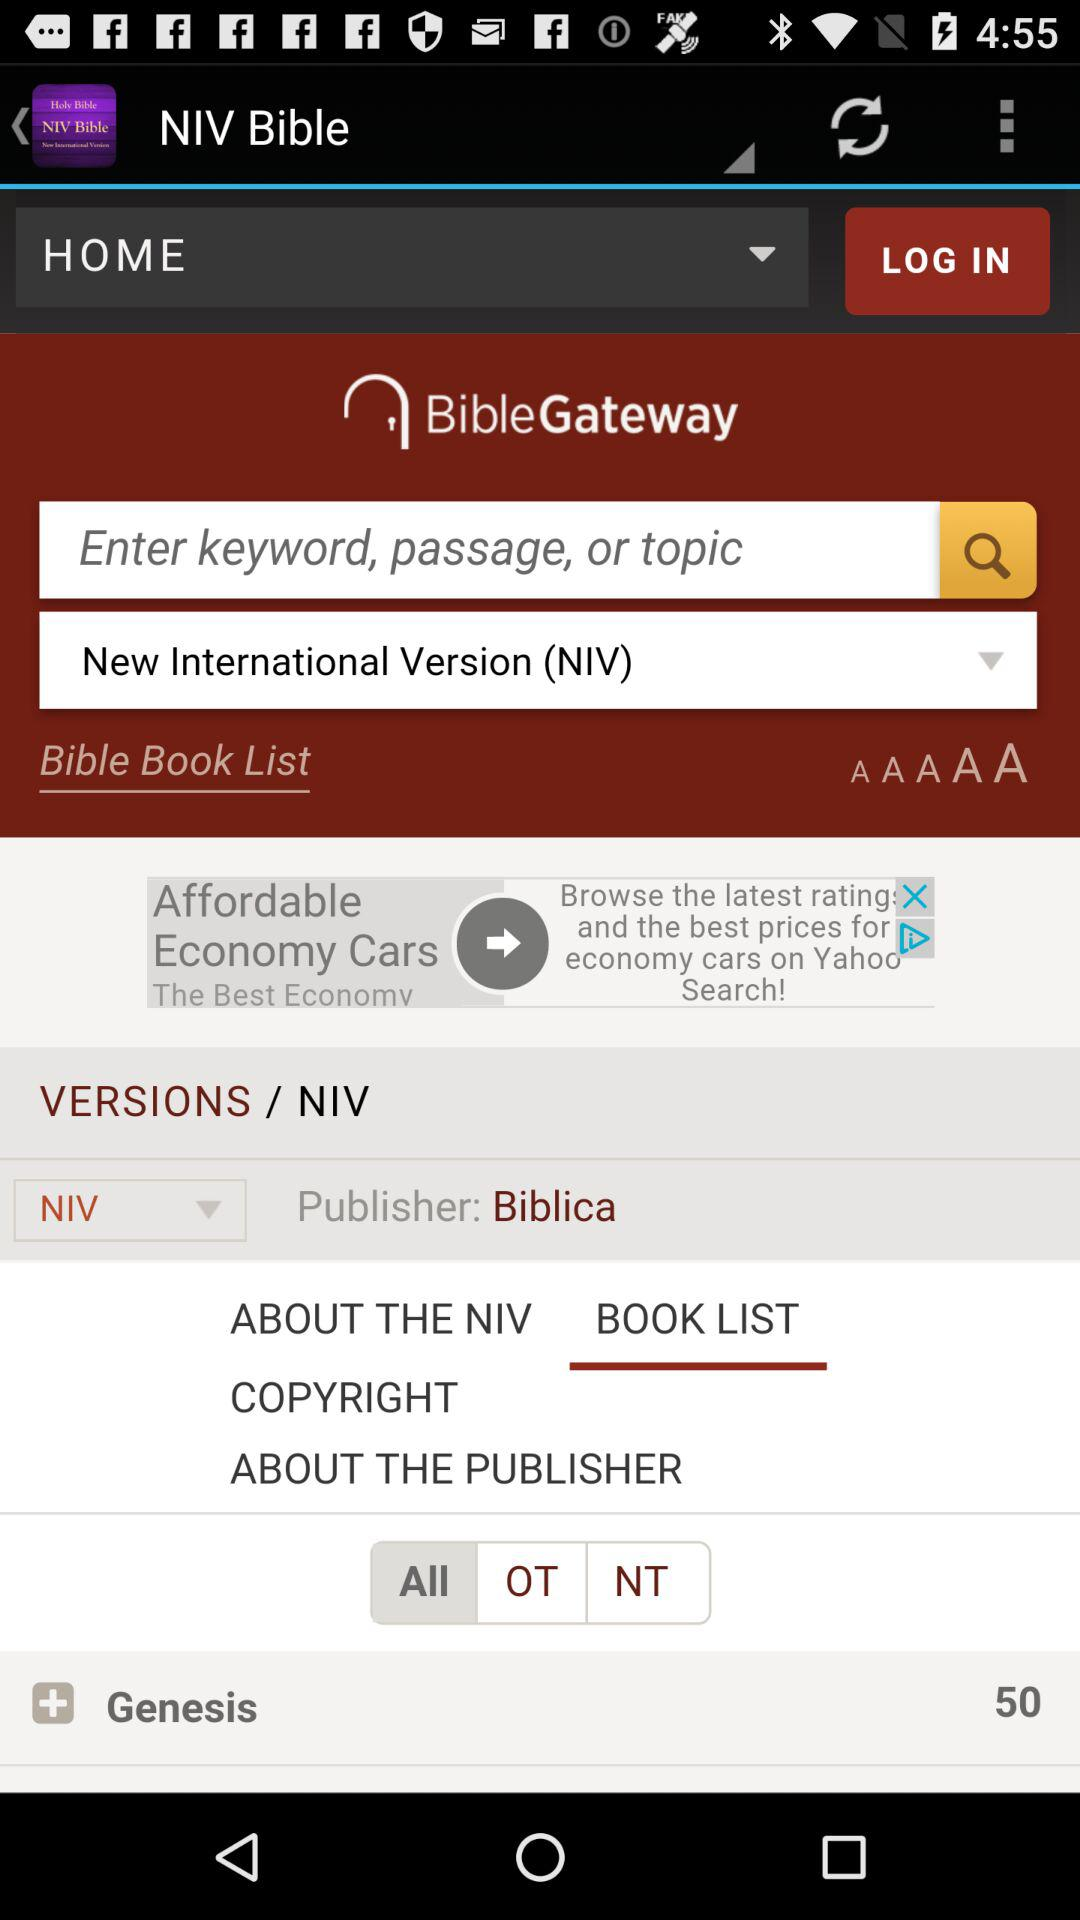How many chapters are there in "Genesis"? There are 50 chapters in "Genesis". 